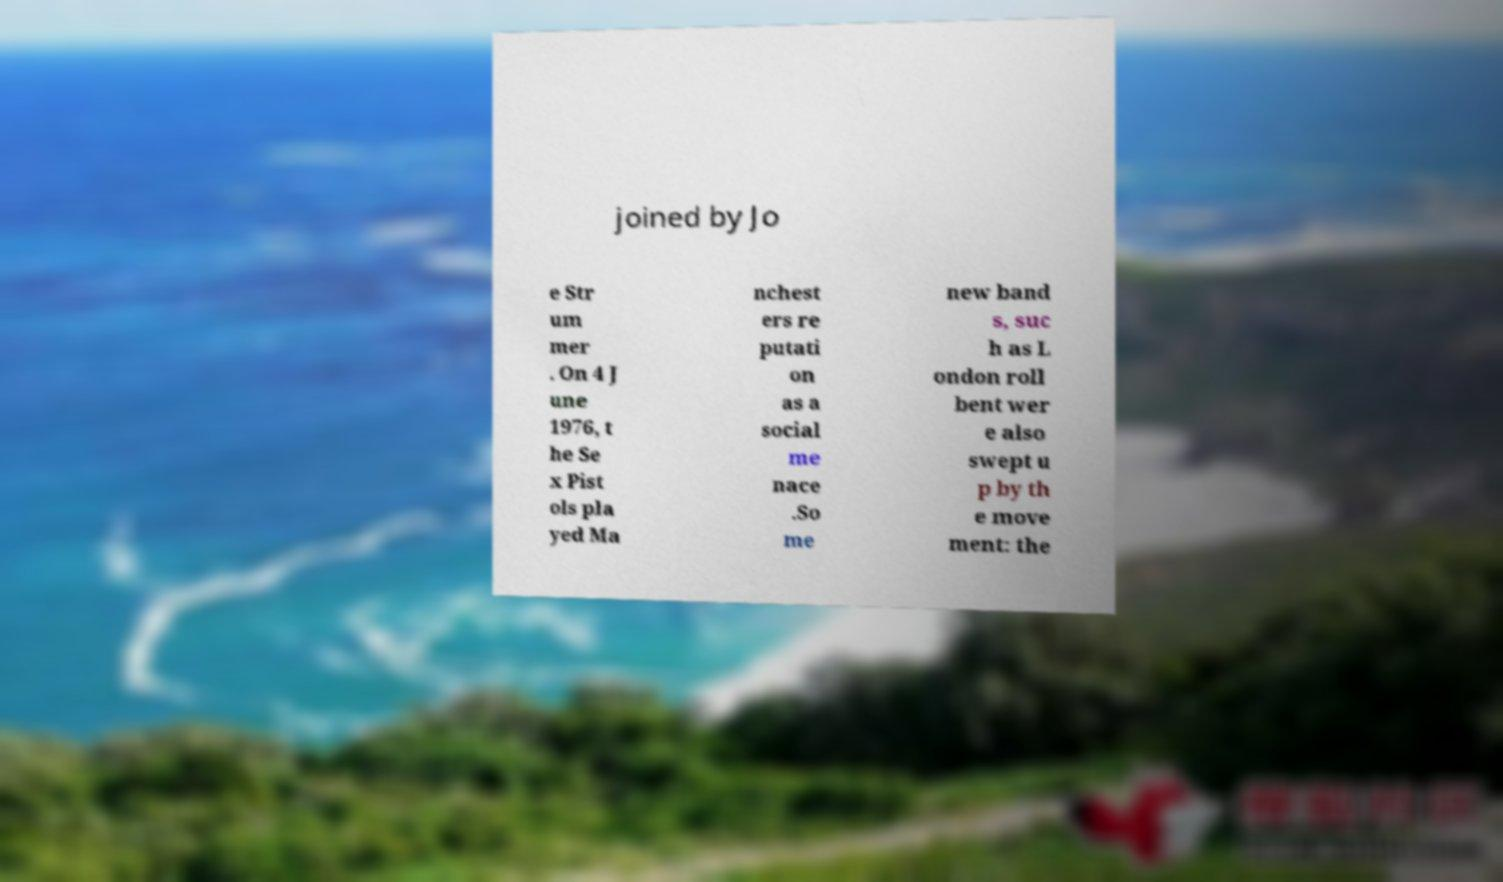Can you read and provide the text displayed in the image?This photo seems to have some interesting text. Can you extract and type it out for me? joined by Jo e Str um mer . On 4 J une 1976, t he Se x Pist ols pla yed Ma nchest ers re putati on as a social me nace .So me new band s, suc h as L ondon roll bent wer e also swept u p by th e move ment: the 